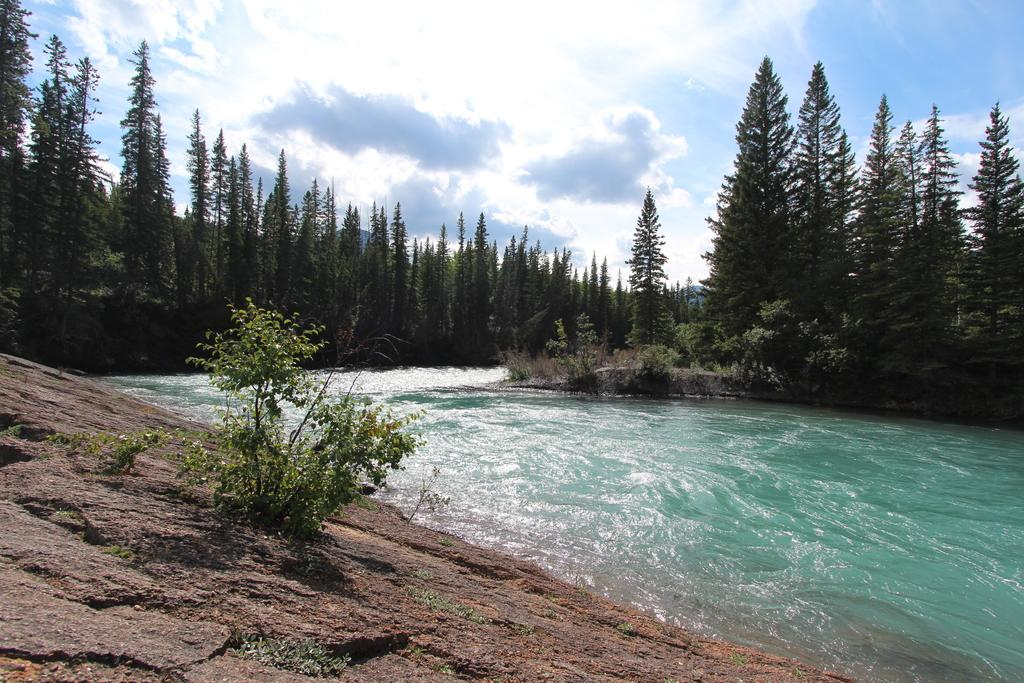What type of natural feature is present in the image? There is a river in the image. What is happening to the water in the river? Water is flowing through the river. What can be found near the river? Rocks and trees are present near the river. What is the color of the sky in the image? The sky is blue in the image. Can you tell me how many chess pieces are floating in the river? There are no chess pieces present in the image; it features a river with flowing water, rocks, trees, and a blue sky. 